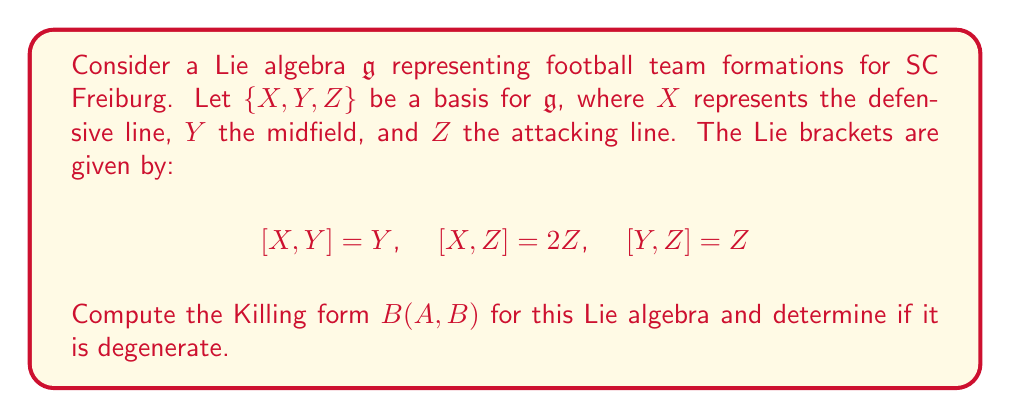Can you solve this math problem? To compute the Killing form for the given Lie algebra, we follow these steps:

1) The Killing form is defined as $B(A,B) = \text{tr}(\text{ad}_A \circ \text{ad}_B)$, where $\text{ad}_A$ is the adjoint representation of $A$.

2) First, we need to find the matrix representations of $\text{ad}_X$, $\text{ad}_Y$, and $\text{ad}_Z$:

   $\text{ad}_X = \begin{pmatrix} 0 & 0 & 0 \\ 0 & 1 & 0 \\ 0 & 0 & 2 \end{pmatrix}$

   $\text{ad}_Y = \begin{pmatrix} 0 & 0 & 0 \\ -1 & 0 & 0 \\ 0 & -1 & 0 \end{pmatrix}$

   $\text{ad}_Z = \begin{pmatrix} 0 & 0 & 0 \\ 0 & 0 & 0 \\ -2 & -1 & 0 \end{pmatrix}$

3) Now, we compute $B(A,B)$ for all pairs of basis elements:

   $B(X,X) = \text{tr}(\text{ad}_X \circ \text{ad}_X) = 0 + 1 + 4 = 5$
   
   $B(X,Y) = \text{tr}(\text{ad}_X \circ \text{ad}_Y) = 0 - 1 + 0 = -1$
   
   $B(X,Z) = \text{tr}(\text{ad}_X \circ \text{ad}_Z) = 0 + 0 - 4 = -4$
   
   $B(Y,X) = \text{tr}(\text{ad}_Y \circ \text{ad}_X) = 0 - 1 + 0 = -1$
   
   $B(Y,Y) = \text{tr}(\text{ad}_Y \circ \text{ad}_Y) = 0 + 0 + 0 = 0$
   
   $B(Y,Z) = \text{tr}(\text{ad}_Y \circ \text{ad}_Z) = 0 + 0 - 1 = -1$
   
   $B(Z,X) = \text{tr}(\text{ad}_Z \circ \text{ad}_X) = 0 + 0 - 4 = -4$
   
   $B(Z,Y) = \text{tr}(\text{ad}_Z \circ \text{ad}_Y) = 0 + 0 - 1 = -1$
   
   $B(Z,Z) = \text{tr}(\text{ad}_Z \circ \text{ad}_Z) = 0 + 0 + 0 = 0$

4) The Killing form can be represented as a matrix:

   $B = \begin{pmatrix} 5 & -1 & -4 \\ -1 & 0 & -1 \\ -4 & -1 & 0 \end{pmatrix}$

5) To determine if the Killing form is degenerate, we calculate its determinant:

   $\det(B) = 5(0) - (-1)(-1) + (-4)(-1) - (-4)(0) + (-1)(-4) - 5(-1) = 0 - 1 + 4 + 0 + 4 + 5 = 12$

Since the determinant is non-zero, the Killing form is non-degenerate.
Answer: The Killing form for the given Lie algebra is:

$$B = \begin{pmatrix} 5 & -1 & -4 \\ -1 & 0 & -1 \\ -4 & -1 & 0 \end{pmatrix}$$

The Killing form is non-degenerate as $\det(B) = 12 \neq 0$. 